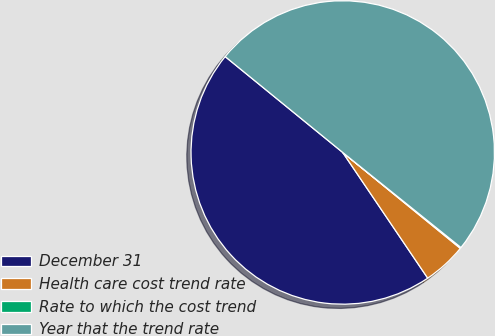Convert chart to OTSL. <chart><loc_0><loc_0><loc_500><loc_500><pie_chart><fcel>December 31<fcel>Health care cost trend rate<fcel>Rate to which the cost trend<fcel>Year that the trend rate<nl><fcel>45.35%<fcel>4.65%<fcel>0.11%<fcel>49.89%<nl></chart> 